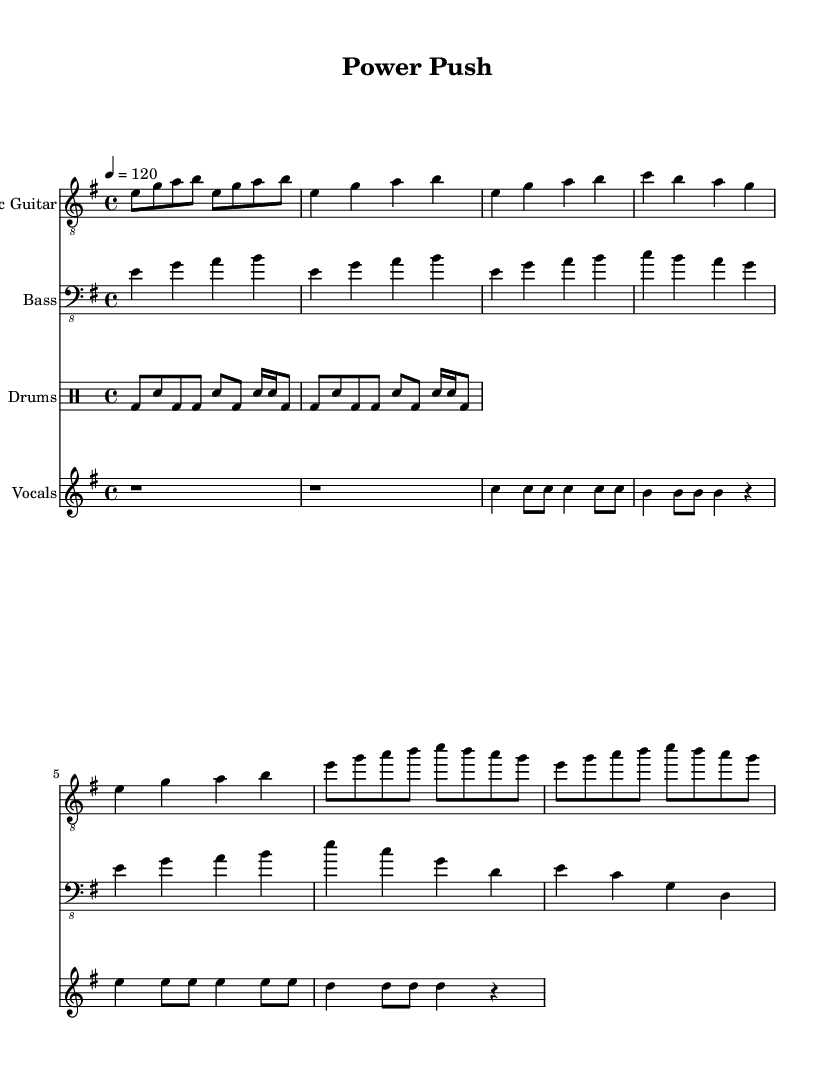What is the key signature of this music? The key signature shows E minor, which consists of one sharp note (F#). This is identified at the beginning of the staff where the sharps and flats are indicated.
Answer: E minor What is the tempo marking in this piece? The tempo is marked at quarter note equals 120. This is found in the global section of the score, indicating the speed of the music.
Answer: 120 How many measures are there in the verse? The verse contains four measures. Counting the measures indicated in the sequence for the verse part gives a total of four measures.
Answer: Four What type of drum beat is featured in the drums part? The drums feature a basic funk-inspired beat. This is evident from the rhythmic patterns used, showing syncopation typical of funk music.
Answer: Funk What are the lyrics for the chorus section? The chorus lyrics are: "Push your li -- mits, break the mold." This is taken directly from the lyrics section associated with the vocal staff, focusing on the motivational line.
Answer: Push your li -- mits, break the mold Which instrument plays the bassline? The bassline is played by the bass guitar. This can be deduced from the specific staff labeled "Bass" in the score.
Answer: Bass guitar How many different instruments are presented in the score? There are four different instruments presented: Electric Guitar, Bass, Drums, and Vocals. Each one is listed separately on its own staff.
Answer: Four 